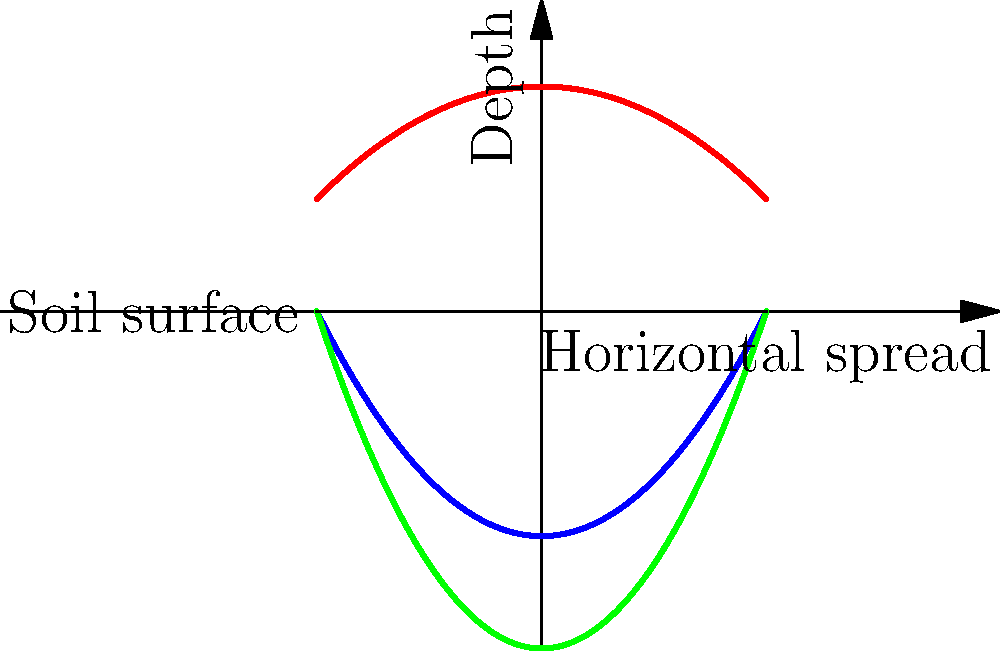Based on the graph depicting the root systems of three medicinal plants native to North America, which plant is likely to be most resilient to drought conditions, and why? To determine which plant is most resilient to drought conditions, we need to analyze the root systems shown in the graph:

1. Common Echinacea (blue curve):
   - Roots spread moderately wide
   - Reaches medium depth

2. Rare Goldenseal (red curve):
   - Roots spread the widest
   - Remains relatively shallow

3. Rare American Ginseng (green curve):
   - Roots have a narrower spread
   - Reaches the greatest depth

In drought conditions, plants with deeper root systems are generally more resilient because:

a) They can access water from deeper soil layers where moisture is retained longer.
b) They are less affected by surface soil drying.

The plant with the deepest roots in this graph is the Rare American Ginseng (green curve). Its root system extends significantly deeper than the other two plants, although it has a narrower horizontal spread.

While a wide horizontal spread (as seen in Goldenseal) can be beneficial for capturing surface water, it's less effective during drought when the top layers of soil dry out quickly.

The Common Echinacea has a moderate depth and spread, making it somewhat drought-tolerant, but not as resilient as the American Ginseng in prolonged dry conditions.

Therefore, based on root depth, the Rare American Ginseng is likely to be the most resilient to drought conditions among these three plants.
Answer: Rare American Ginseng, due to its deepest root system. 